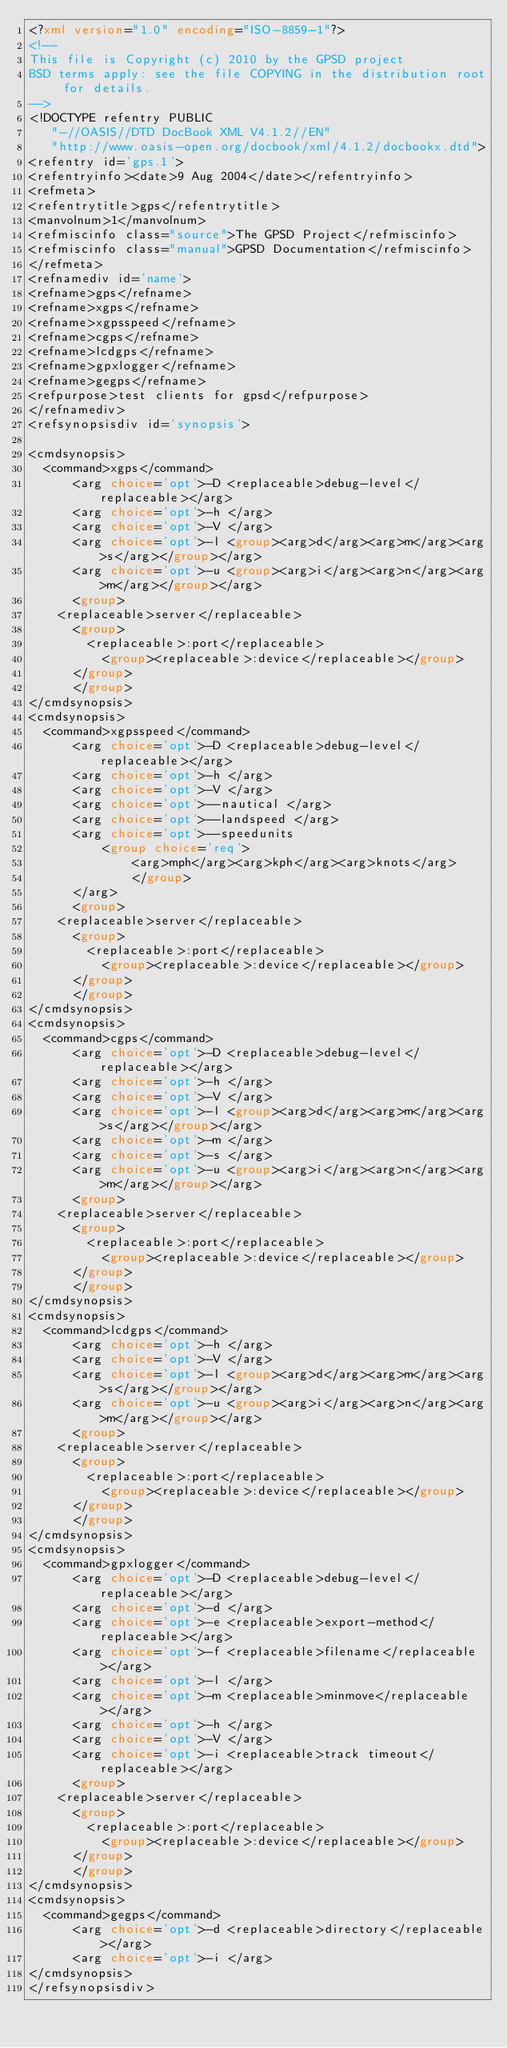Convert code to text. <code><loc_0><loc_0><loc_500><loc_500><_XML_><?xml version="1.0" encoding="ISO-8859-1"?>
<!--
This file is Copyright (c) 2010 by the GPSD project
BSD terms apply: see the file COPYING in the distribution root for details.
-->
<!DOCTYPE refentry PUBLIC
   "-//OASIS//DTD DocBook XML V4.1.2//EN"
   "http://www.oasis-open.org/docbook/xml/4.1.2/docbookx.dtd">
<refentry id='gps.1'>
<refentryinfo><date>9 Aug 2004</date></refentryinfo>
<refmeta>
<refentrytitle>gps</refentrytitle>
<manvolnum>1</manvolnum>
<refmiscinfo class="source">The GPSD Project</refmiscinfo>
<refmiscinfo class="manual">GPSD Documentation</refmiscinfo>
</refmeta>
<refnamediv id='name'>
<refname>gps</refname>
<refname>xgps</refname>
<refname>xgpsspeed</refname>
<refname>cgps</refname>
<refname>lcdgps</refname>
<refname>gpxlogger</refname>
<refname>gegps</refname>
<refpurpose>test clients for gpsd</refpurpose>
</refnamediv>
<refsynopsisdiv id='synopsis'>

<cmdsynopsis>
  <command>xgps</command>
      <arg choice='opt'>-D <replaceable>debug-level</replaceable></arg>
      <arg choice='opt'>-h </arg>
      <arg choice='opt'>-V </arg>
      <arg choice='opt'>-l <group><arg>d</arg><arg>m</arg><arg>s</arg></group></arg>
      <arg choice='opt'>-u <group><arg>i</arg><arg>n</arg><arg>m</arg></group></arg>
      <group>
	<replaceable>server</replaceable>
	  <group>
	    <replaceable>:port</replaceable>
	      <group><replaceable>:device</replaceable></group>
	  </group>
      </group>
</cmdsynopsis>
<cmdsynopsis>
  <command>xgpsspeed</command>
      <arg choice='opt'>-D <replaceable>debug-level</replaceable></arg>
      <arg choice='opt'>-h </arg>
      <arg choice='opt'>-V </arg>
      <arg choice='opt'>--nautical </arg>
      <arg choice='opt'>--landspeed </arg>
      <arg choice='opt'>--speedunits
	      <group choice='req'>
		      <arg>mph</arg><arg>kph</arg><arg>knots</arg>
              </group>
      </arg>
      <group>
	<replaceable>server</replaceable>
	  <group>
	    <replaceable>:port</replaceable>
	      <group><replaceable>:device</replaceable></group>
	  </group>
      </group>
</cmdsynopsis>
<cmdsynopsis>
  <command>cgps</command>
      <arg choice='opt'>-D <replaceable>debug-level</replaceable></arg>
      <arg choice='opt'>-h </arg>
      <arg choice='opt'>-V </arg>
      <arg choice='opt'>-l <group><arg>d</arg><arg>m</arg><arg>s</arg></group></arg>
      <arg choice='opt'>-m </arg>
      <arg choice='opt'>-s </arg>
      <arg choice='opt'>-u <group><arg>i</arg><arg>n</arg><arg>m</arg></group></arg>
      <group>
	<replaceable>server</replaceable>
	  <group>
	    <replaceable>:port</replaceable>
	      <group><replaceable>:device</replaceable></group>
	  </group>
      </group>
</cmdsynopsis>
<cmdsynopsis>
  <command>lcdgps</command>
      <arg choice='opt'>-h </arg>
      <arg choice='opt'>-V </arg>
      <arg choice='opt'>-l <group><arg>d</arg><arg>m</arg><arg>s</arg></group></arg>
      <arg choice='opt'>-u <group><arg>i</arg><arg>n</arg><arg>m</arg></group></arg>
      <group>
	<replaceable>server</replaceable>
	  <group>
	    <replaceable>:port</replaceable>
	      <group><replaceable>:device</replaceable></group>
	  </group>
      </group>
</cmdsynopsis>
<cmdsynopsis>
  <command>gpxlogger</command>
      <arg choice='opt'>-D <replaceable>debug-level</replaceable></arg>
      <arg choice='opt'>-d </arg>
      <arg choice='opt'>-e <replaceable>export-method</replaceable></arg>
      <arg choice='opt'>-f <replaceable>filename</replaceable></arg>
      <arg choice='opt'>-l </arg>
      <arg choice='opt'>-m <replaceable>minmove</replaceable></arg>
      <arg choice='opt'>-h </arg>
      <arg choice='opt'>-V </arg>
      <arg choice='opt'>-i <replaceable>track timeout</replaceable></arg>
      <group>
	<replaceable>server</replaceable>
	  <group>
	    <replaceable>:port</replaceable>
	      <group><replaceable>:device</replaceable></group>
	  </group>
      </group>
</cmdsynopsis>
<cmdsynopsis>
  <command>gegps</command>
      <arg choice='opt'>-d <replaceable>directory</replaceable></arg>
      <arg choice='opt'>-i </arg>
</cmdsynopsis>
</refsynopsisdiv>
</code> 